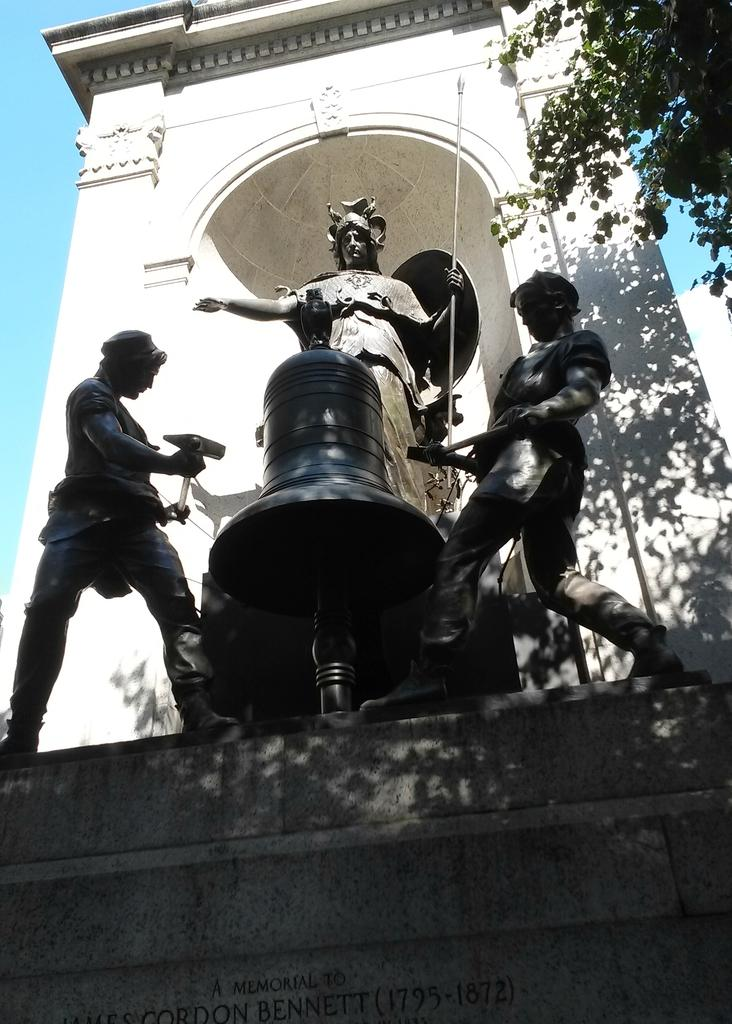What type of objects can be seen in the image? There are statues in the image. How many statues are there? There are three statues in the image. Can you describe one of the statues? One of the statues resembles a bell. What else can be seen in the image besides the statues? Trees are present in the image. Is there any text visible in the image? Yes, there is text written on a wall in the image. What type of company is depicted in the image? There is no company depicted in the image; it features statues, trees, and text on a wall. What type of flesh can be seen on the statues in the image? The statues are not made of flesh; they are likely made of stone or another material. 